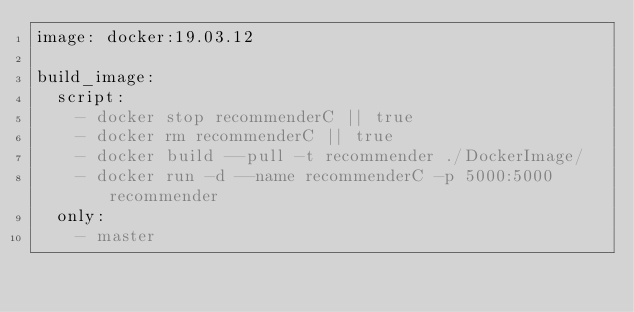Convert code to text. <code><loc_0><loc_0><loc_500><loc_500><_YAML_>image: docker:19.03.12

build_image:
  script:
    - docker stop recommenderC || true
    - docker rm recommenderC || true
    - docker build --pull -t recommender ./DockerImage/
    - docker run -d --name recommenderC -p 5000:5000 recommender
  only:
    - master
</code> 